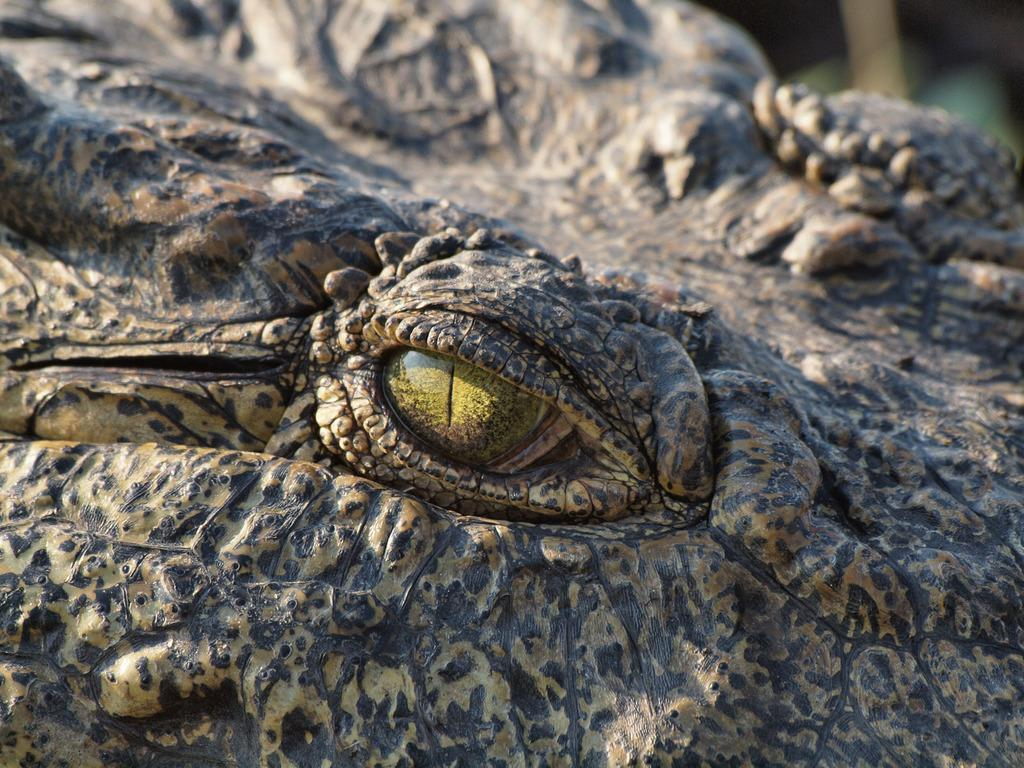What is the main subject of the image? The main subject of the image is an animal's eye. Can you describe the background of the image? The background of the image is blurred. What type of soda is being served in the office in the image? There is no soda or office present in the image; it features an animal's eye with a blurred background. How many vans are parked outside the building in the image? There is no building or van present in the image; it features an animal's eye with a blurred background. 